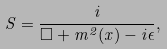<formula> <loc_0><loc_0><loc_500><loc_500>S = \frac { i } { \Box + m ^ { 2 } ( x ) - i \epsilon } ,</formula> 